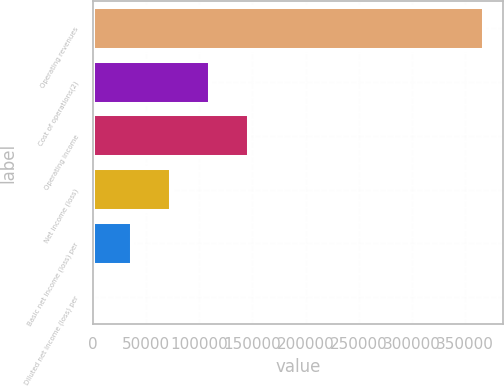<chart> <loc_0><loc_0><loc_500><loc_500><bar_chart><fcel>Operating revenues<fcel>Cost of operations(2)<fcel>Operating income<fcel>Net income (loss)<fcel>Basic net income (loss) per<fcel>Diluted net income (loss) per<nl><fcel>367585<fcel>110276<fcel>147034<fcel>73517.1<fcel>36758.6<fcel>0.14<nl></chart> 